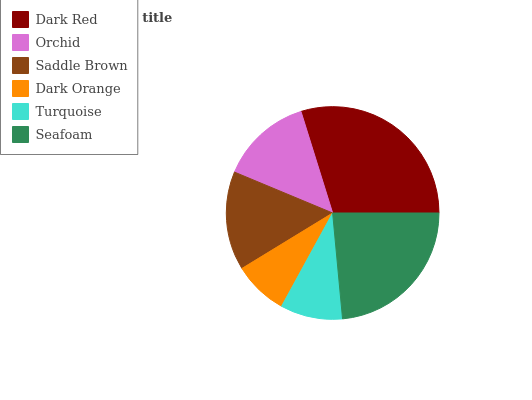Is Dark Orange the minimum?
Answer yes or no. Yes. Is Dark Red the maximum?
Answer yes or no. Yes. Is Orchid the minimum?
Answer yes or no. No. Is Orchid the maximum?
Answer yes or no. No. Is Dark Red greater than Orchid?
Answer yes or no. Yes. Is Orchid less than Dark Red?
Answer yes or no. Yes. Is Orchid greater than Dark Red?
Answer yes or no. No. Is Dark Red less than Orchid?
Answer yes or no. No. Is Saddle Brown the high median?
Answer yes or no. Yes. Is Orchid the low median?
Answer yes or no. Yes. Is Dark Orange the high median?
Answer yes or no. No. Is Turquoise the low median?
Answer yes or no. No. 